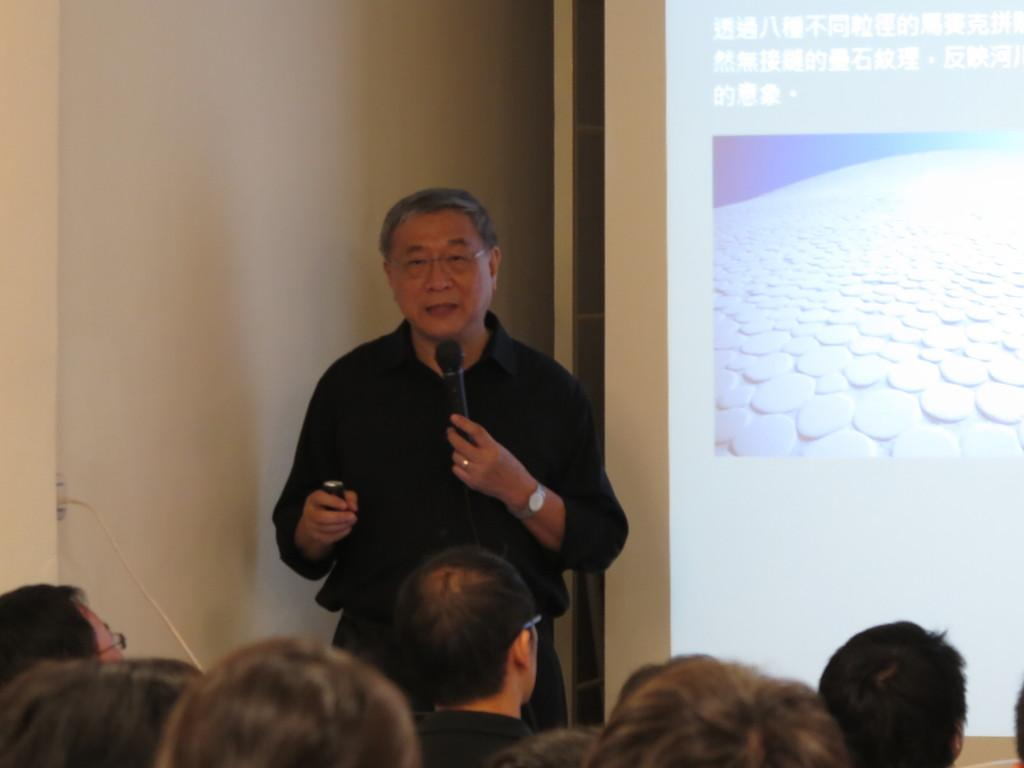What can be seen at the bottom of the image? There are people at the bottom of the image. What is the person in the foreground holding? The person in the foreground is holding a microphone. What is on the wall in the foreground? There is a screen on the wall in the foreground. Is there a veil covering the screen on the wall in the image? There is no mention of a veil in the image, and therefore it cannot be determined if one is present. What type of hospital is depicted in the image? There is no reference to a hospital in the image, so it cannot be determined if one is present. 